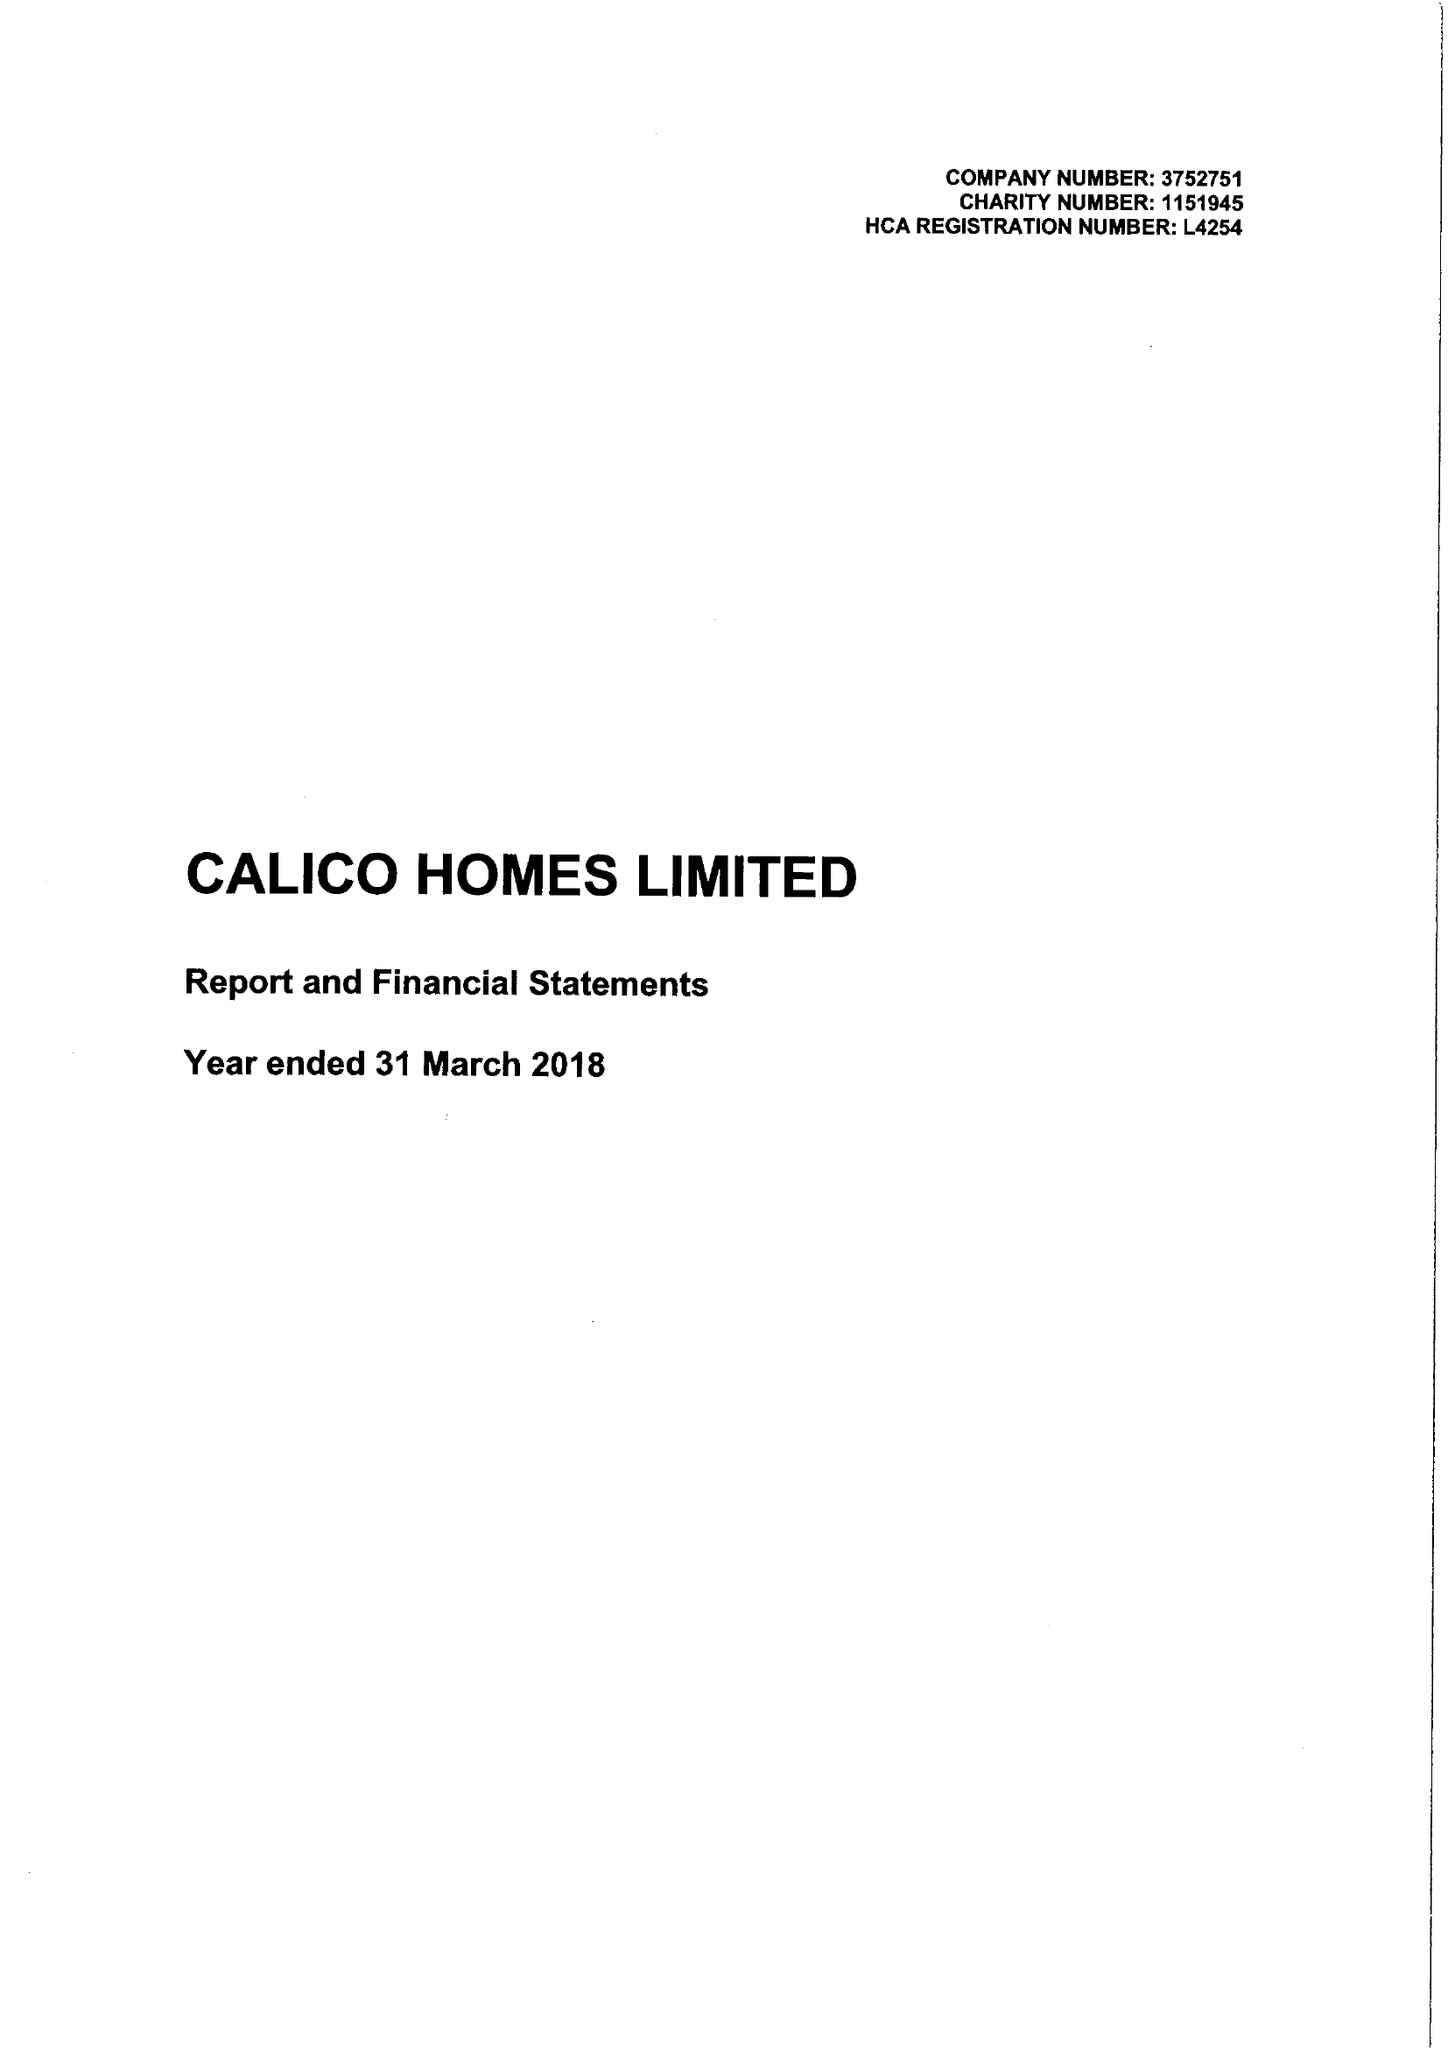What is the value for the address__post_town?
Answer the question using a single word or phrase. BURNLEY 